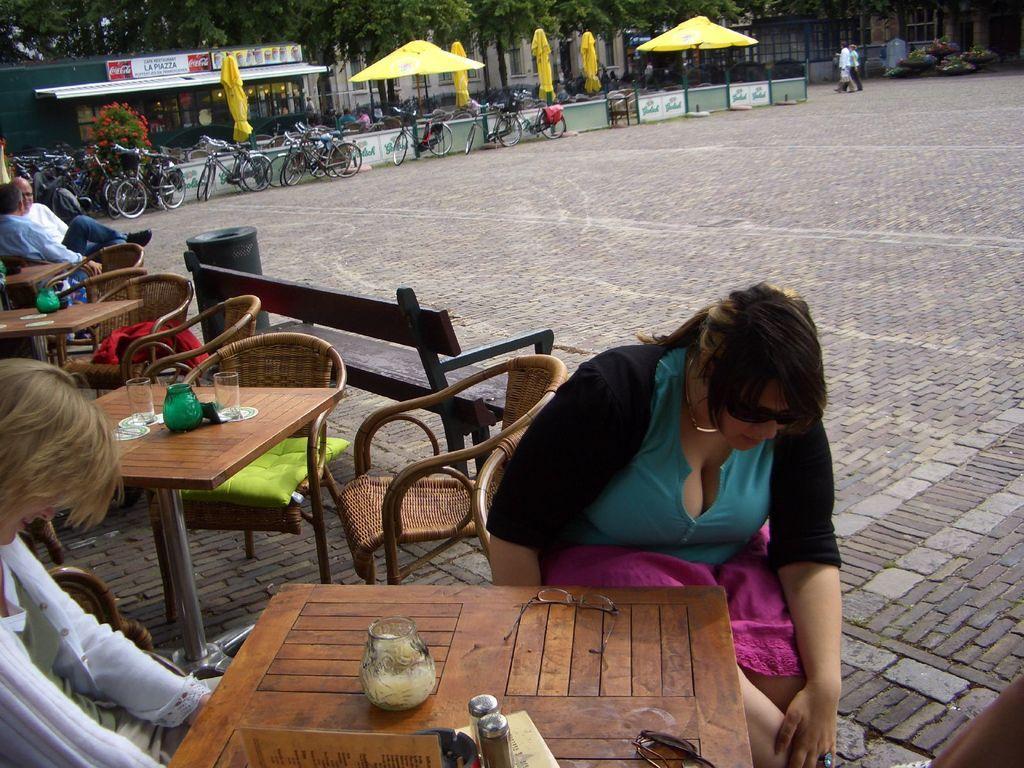Please provide a concise description of this image. In this picture these four persons are sitting on the chair. A far these two persons are walking. We can see Chairs and tables. On the table we can see glasses. On the chair we can see pillow. This is floor. We can see bicycles. There is a tree with flower. On the background we can see trees. There is a building. This is shed and these are tents. this is plant. 